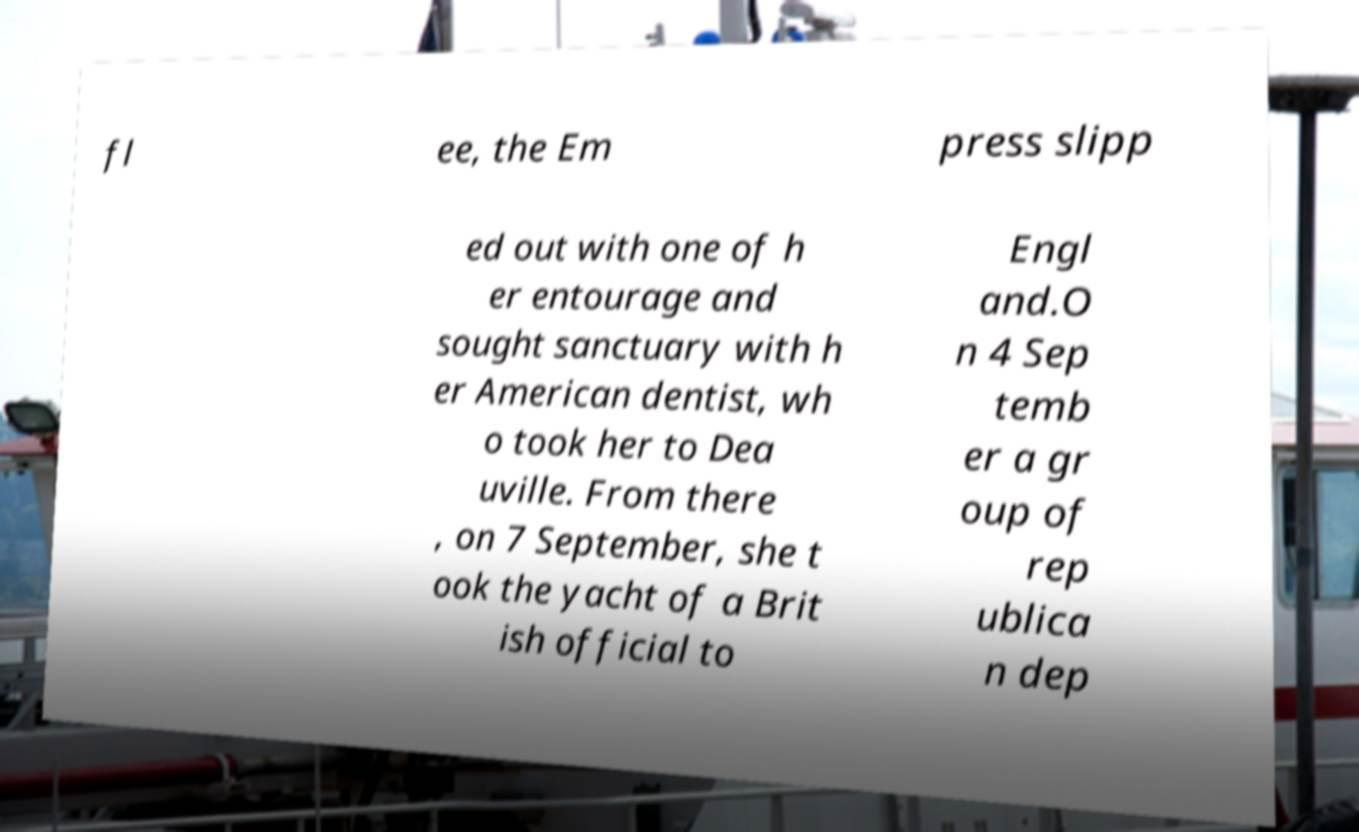Please identify and transcribe the text found in this image. fl ee, the Em press slipp ed out with one of h er entourage and sought sanctuary with h er American dentist, wh o took her to Dea uville. From there , on 7 September, she t ook the yacht of a Brit ish official to Engl and.O n 4 Sep temb er a gr oup of rep ublica n dep 